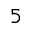Convert formula to latex. <formula><loc_0><loc_0><loc_500><loc_500>_ { 5 }</formula> 